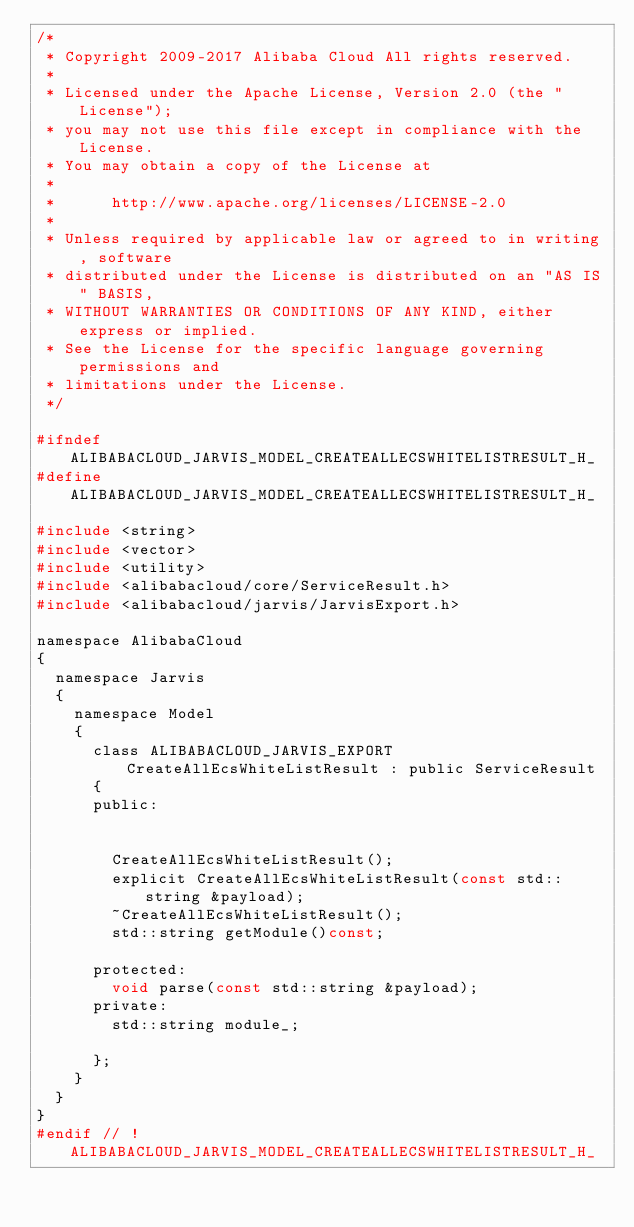<code> <loc_0><loc_0><loc_500><loc_500><_C_>/*
 * Copyright 2009-2017 Alibaba Cloud All rights reserved.
 * 
 * Licensed under the Apache License, Version 2.0 (the "License");
 * you may not use this file except in compliance with the License.
 * You may obtain a copy of the License at
 * 
 *      http://www.apache.org/licenses/LICENSE-2.0
 * 
 * Unless required by applicable law or agreed to in writing, software
 * distributed under the License is distributed on an "AS IS" BASIS,
 * WITHOUT WARRANTIES OR CONDITIONS OF ANY KIND, either express or implied.
 * See the License for the specific language governing permissions and
 * limitations under the License.
 */

#ifndef ALIBABACLOUD_JARVIS_MODEL_CREATEALLECSWHITELISTRESULT_H_
#define ALIBABACLOUD_JARVIS_MODEL_CREATEALLECSWHITELISTRESULT_H_

#include <string>
#include <vector>
#include <utility>
#include <alibabacloud/core/ServiceResult.h>
#include <alibabacloud/jarvis/JarvisExport.h>

namespace AlibabaCloud
{
	namespace Jarvis
	{
		namespace Model
		{
			class ALIBABACLOUD_JARVIS_EXPORT CreateAllEcsWhiteListResult : public ServiceResult
			{
			public:


				CreateAllEcsWhiteListResult();
				explicit CreateAllEcsWhiteListResult(const std::string &payload);
				~CreateAllEcsWhiteListResult();
				std::string getModule()const;

			protected:
				void parse(const std::string &payload);
			private:
				std::string module_;

			};
		}
	}
}
#endif // !ALIBABACLOUD_JARVIS_MODEL_CREATEALLECSWHITELISTRESULT_H_</code> 